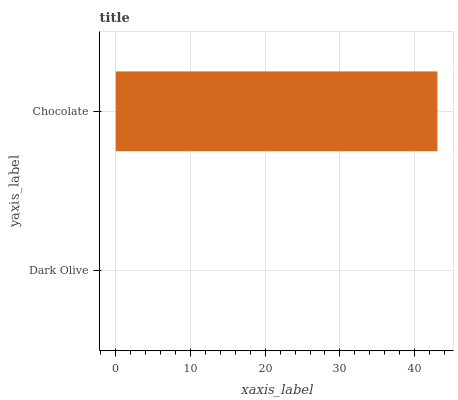Is Dark Olive the minimum?
Answer yes or no. Yes. Is Chocolate the maximum?
Answer yes or no. Yes. Is Chocolate the minimum?
Answer yes or no. No. Is Chocolate greater than Dark Olive?
Answer yes or no. Yes. Is Dark Olive less than Chocolate?
Answer yes or no. Yes. Is Dark Olive greater than Chocolate?
Answer yes or no. No. Is Chocolate less than Dark Olive?
Answer yes or no. No. Is Chocolate the high median?
Answer yes or no. Yes. Is Dark Olive the low median?
Answer yes or no. Yes. Is Dark Olive the high median?
Answer yes or no. No. Is Chocolate the low median?
Answer yes or no. No. 